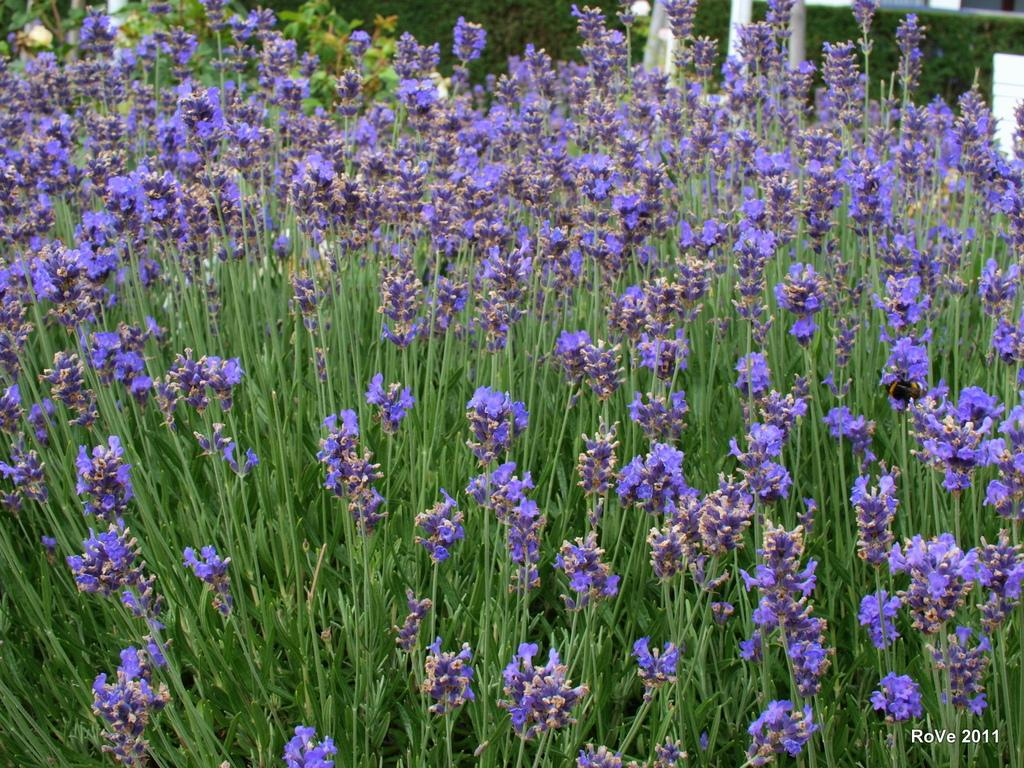What type of plants can be seen in the image? There are flower plants in the image. Is there any text present in the image? Yes, there is text in the bottom right corner of the image. Is there a volcano erupting in the background of the image? No, there is no volcano present in the image. Can you see a battle taking place in the image? No, there is no battle depicted in the image. 